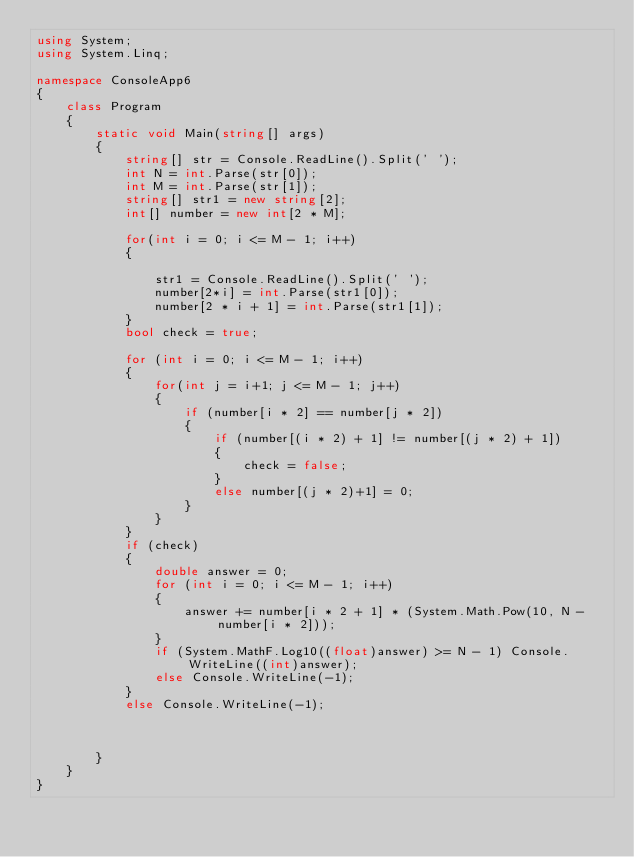<code> <loc_0><loc_0><loc_500><loc_500><_C#_>using System;
using System.Linq;

namespace ConsoleApp6
{
    class Program
    {
        static void Main(string[] args)
        {
            string[] str = Console.ReadLine().Split(' ');
            int N = int.Parse(str[0]);
            int M = int.Parse(str[1]);
            string[] str1 = new string[2];
            int[] number = new int[2 * M];

            for(int i = 0; i <= M - 1; i++)
            {
                
                str1 = Console.ReadLine().Split(' ');
                number[2*i] = int.Parse(str1[0]);
                number[2 * i + 1] = int.Parse(str1[1]);
            }
            bool check = true;

            for (int i = 0; i <= M - 1; i++)
            {
                for(int j = i+1; j <= M - 1; j++)
                {
                    if (number[i * 2] == number[j * 2])
                    {
                        if (number[(i * 2) + 1] != number[(j * 2) + 1])
                        {
                            check = false;
                        }
                        else number[(j * 2)+1] = 0;
                    }
                }
            }
            if (check)
            {
                double answer = 0;
                for (int i = 0; i <= M - 1; i++)
                {
                    answer += number[i * 2 + 1] * (System.Math.Pow(10, N - number[i * 2]));
                }
                if (System.MathF.Log10((float)answer) >= N - 1) Console.WriteLine((int)answer);
                else Console.WriteLine(-1);
            }
            else Console.WriteLine(-1);



        }
    }
}
</code> 